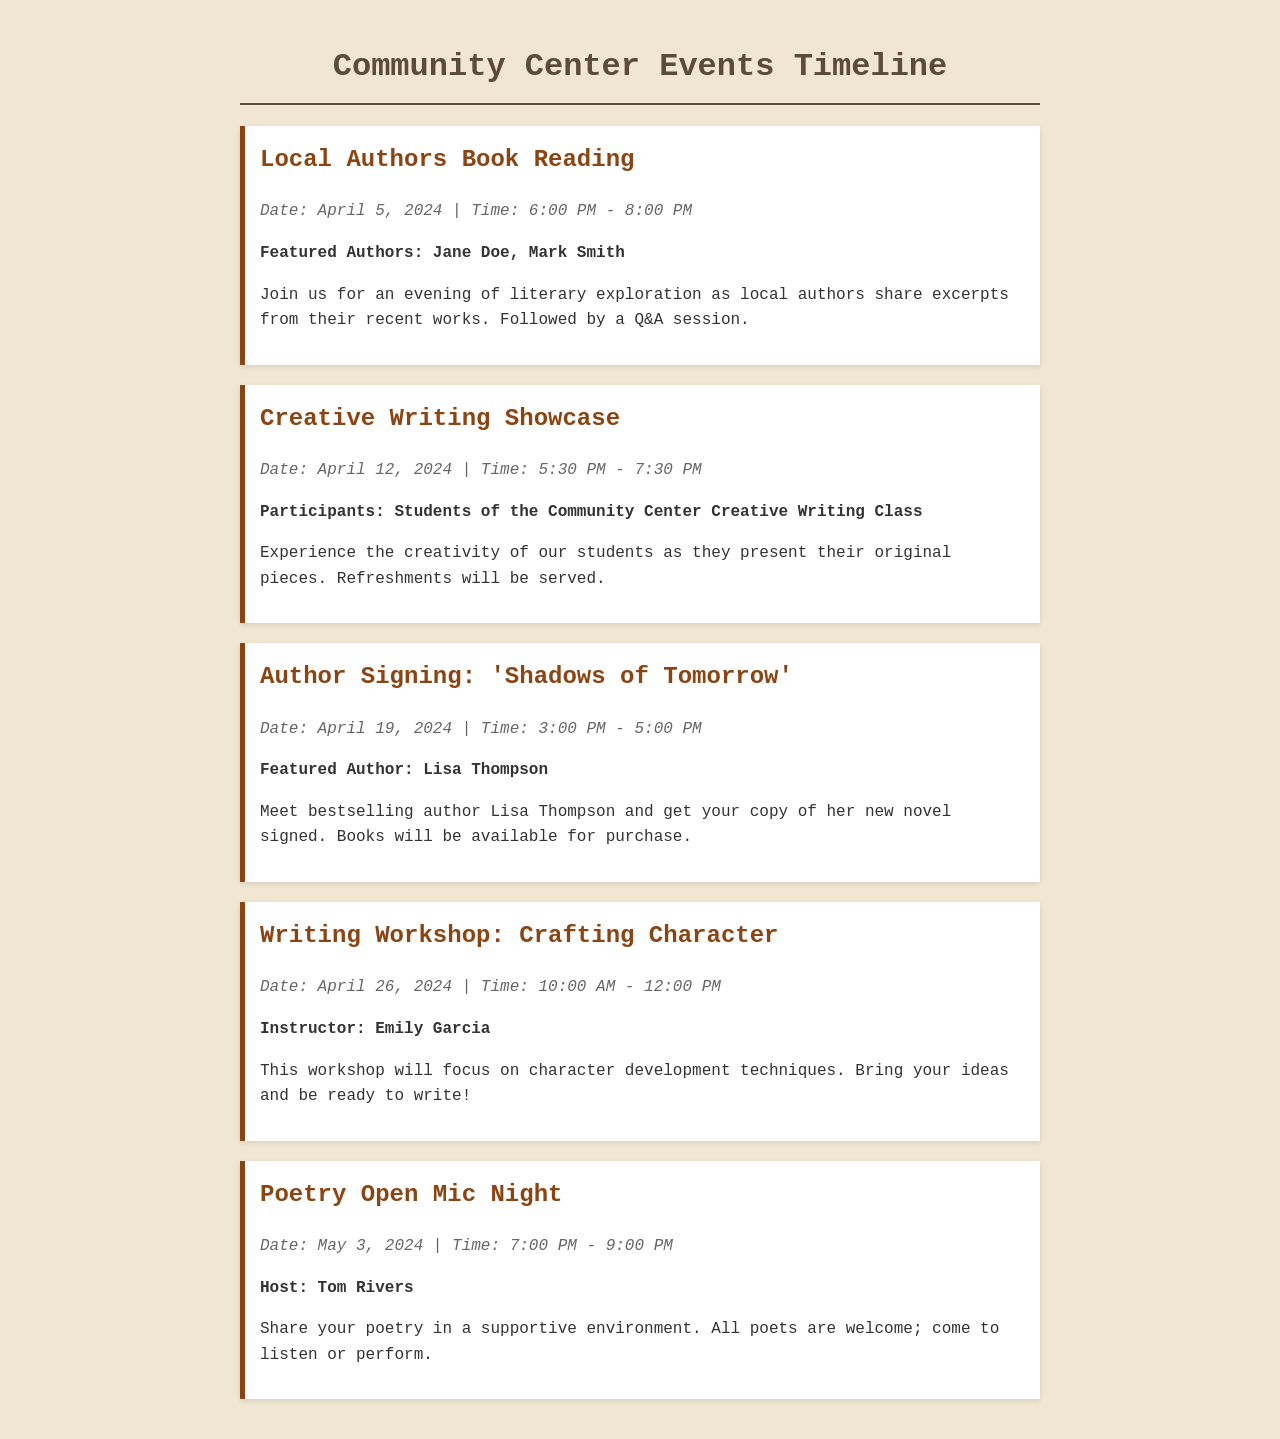What is the date of the Local Authors Book Reading? The date is mentioned in the event details under "Local Authors Book Reading."
Answer: April 5, 2024 Who is the featured author for the Author Signing event? The featured author is listed in the "Author Signing" event section.
Answer: Lisa Thompson What time does the Creative Writing Showcase begin? The starting time is noted in the event info of the "Creative Writing Showcase."
Answer: 5:30 PM How many events are scheduled for April? By counting the events listed in April, we can determine the total.
Answer: Four Who is hosting the Poetry Open Mic Night? The host's name is provided in the event description for "Poetry Open Mic Night."
Answer: Tom Rivers What type of event is scheduled on April 26, 2024? The type of event is specified in the title of the event scheduled on that date.
Answer: Writing Workshop What is the main focus of the Writing Workshop? The focus is described in the event details of the "Writing Workshop."
Answer: Character development techniques What is included in the Creative Writing Showcase event? The description of the event outlines what happens during it.
Answer: Present original pieces 